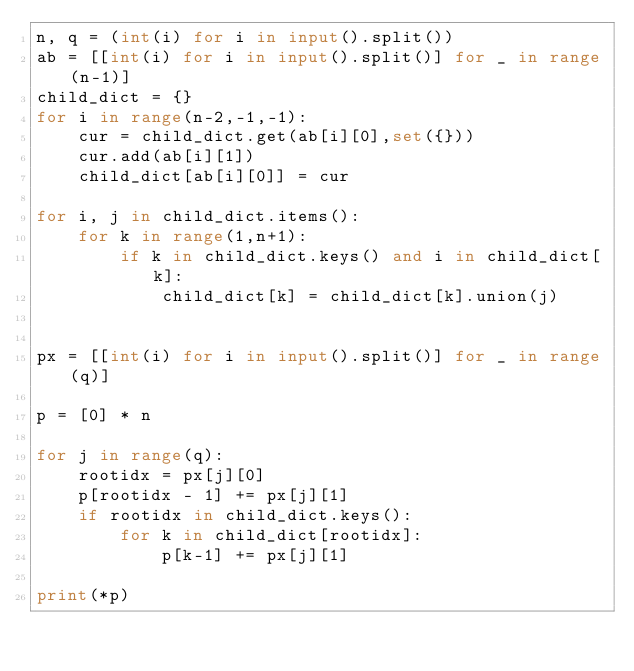<code> <loc_0><loc_0><loc_500><loc_500><_Python_>n, q = (int(i) for i in input().split())
ab = [[int(i) for i in input().split()] for _ in range(n-1)]
child_dict = {}
for i in range(n-2,-1,-1):
    cur = child_dict.get(ab[i][0],set({}))
    cur.add(ab[i][1])
    child_dict[ab[i][0]] = cur

for i, j in child_dict.items():
    for k in range(1,n+1):
        if k in child_dict.keys() and i in child_dict[k]:
            child_dict[k] = child_dict[k].union(j)


px = [[int(i) for i in input().split()] for _ in range(q)]

p = [0] * n

for j in range(q):
    rootidx = px[j][0]
    p[rootidx - 1] += px[j][1]
    if rootidx in child_dict.keys():
        for k in child_dict[rootidx]:
            p[k-1] += px[j][1]

print(*p)</code> 